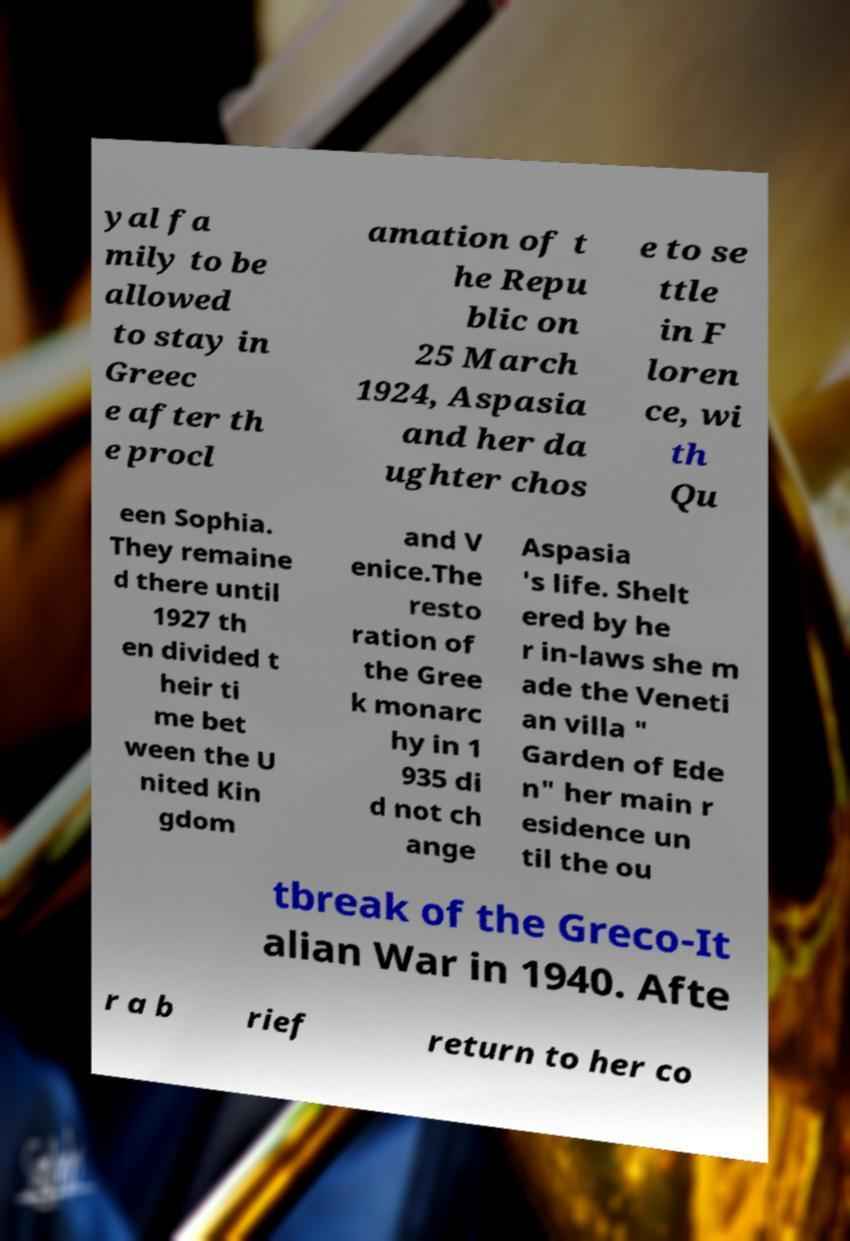Please read and relay the text visible in this image. What does it say? yal fa mily to be allowed to stay in Greec e after th e procl amation of t he Repu blic on 25 March 1924, Aspasia and her da ughter chos e to se ttle in F loren ce, wi th Qu een Sophia. They remaine d there until 1927 th en divided t heir ti me bet ween the U nited Kin gdom and V enice.The resto ration of the Gree k monarc hy in 1 935 di d not ch ange Aspasia 's life. Shelt ered by he r in-laws she m ade the Veneti an villa " Garden of Ede n" her main r esidence un til the ou tbreak of the Greco-It alian War in 1940. Afte r a b rief return to her co 